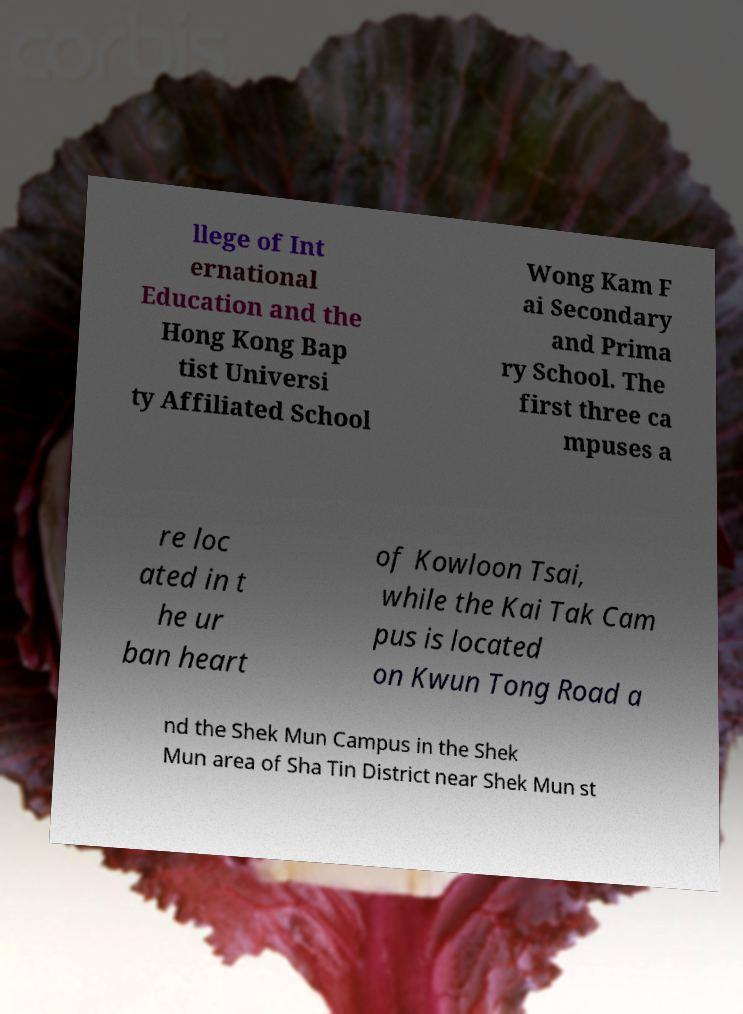Could you extract and type out the text from this image? llege of Int ernational Education and the Hong Kong Bap tist Universi ty Affiliated School Wong Kam F ai Secondary and Prima ry School. The first three ca mpuses a re loc ated in t he ur ban heart of Kowloon Tsai, while the Kai Tak Cam pus is located on Kwun Tong Road a nd the Shek Mun Campus in the Shek Mun area of Sha Tin District near Shek Mun st 